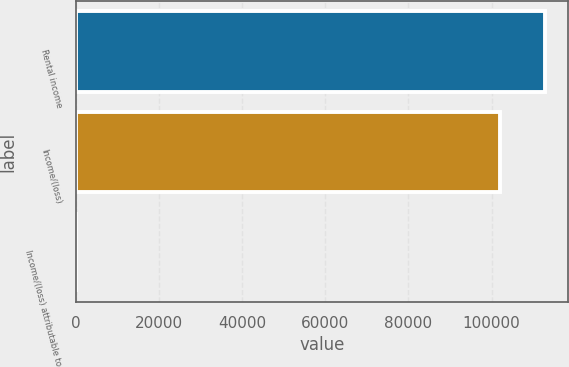<chart> <loc_0><loc_0><loc_500><loc_500><bar_chart><fcel>Rental income<fcel>Income/(loss)<fcel>Income/(loss) attributable to<nl><fcel>112745<fcel>102086<fcel>0.5<nl></chart> 